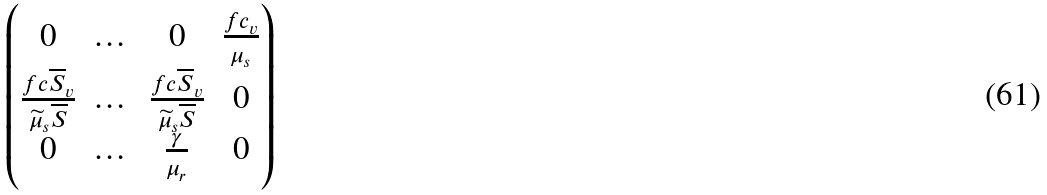Convert formula to latex. <formula><loc_0><loc_0><loc_500><loc_500>\begin{pmatrix} 0 & \dots & 0 & \frac { f c _ { v } } { \mu _ { s } } \\ \frac { f c \overline { S } _ { v } } { \widetilde { \mu } _ { s } \overline { S } } & \dots & \frac { f c \overline { S } _ { v } } { \widetilde { \mu } _ { s } \overline { S } } & 0 \\ 0 & \dots & \frac { \gamma } { \mu _ { r } } & 0 \end{pmatrix}</formula> 